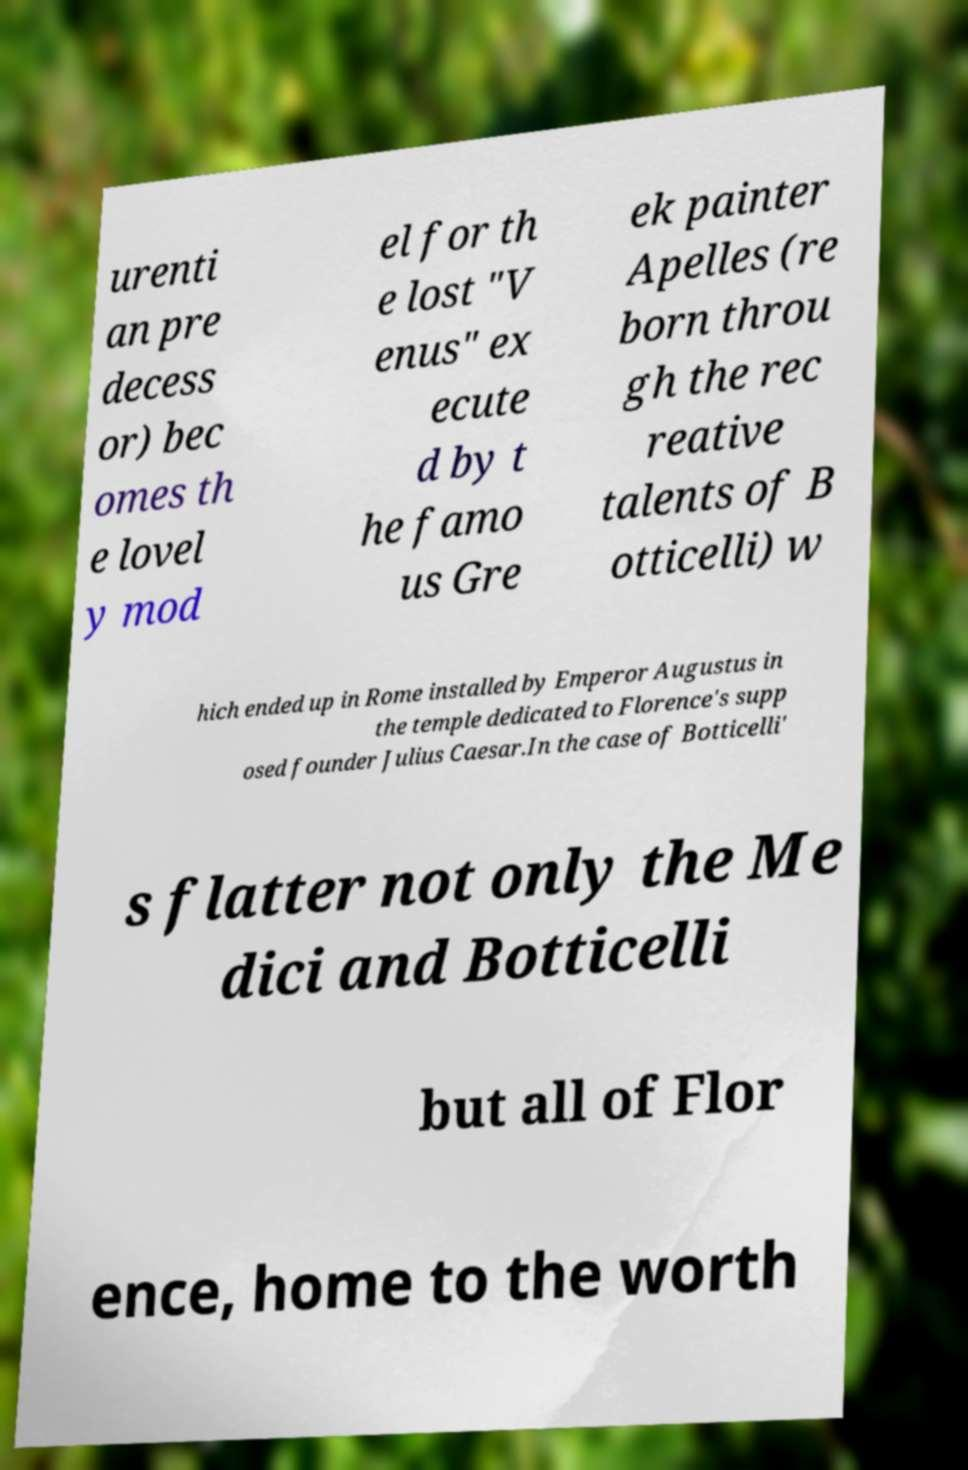Could you assist in decoding the text presented in this image and type it out clearly? urenti an pre decess or) bec omes th e lovel y mod el for th e lost "V enus" ex ecute d by t he famo us Gre ek painter Apelles (re born throu gh the rec reative talents of B otticelli) w hich ended up in Rome installed by Emperor Augustus in the temple dedicated to Florence's supp osed founder Julius Caesar.In the case of Botticelli' s flatter not only the Me dici and Botticelli but all of Flor ence, home to the worth 